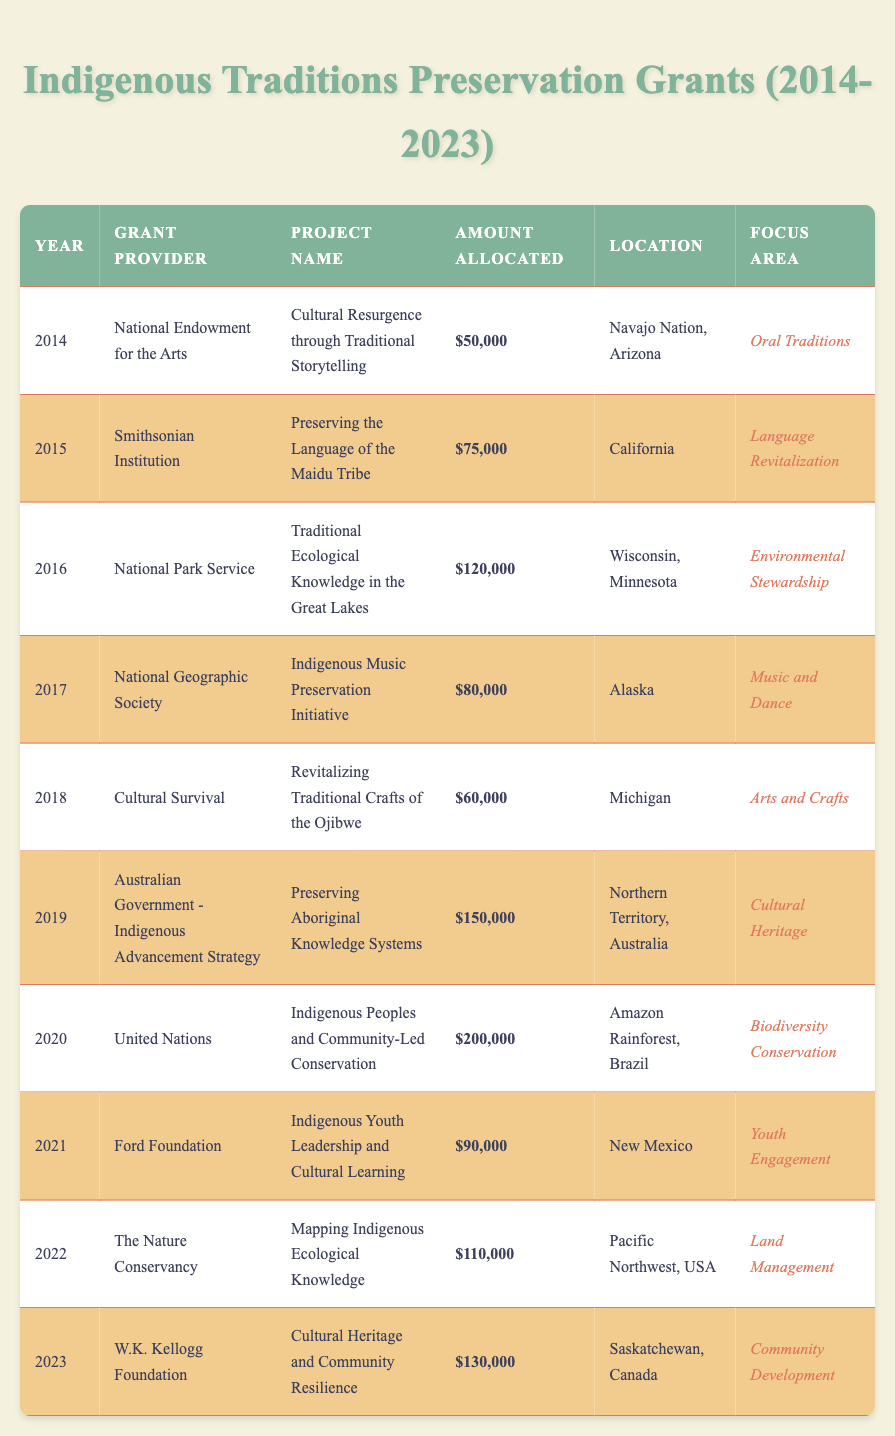What is the largest grant amount allocated in a single year? The table lists the amounts allocated each year, with the largest being $200,000 in 2020.
Answer: $200,000 Which project focused on language revitalization? The project "Preserving the Language of the Maidu Tribe" in 2015 targets language revitalization and is listed in the table.
Answer: Preserving the Language of the Maidu Tribe In which year was the "Cultural Resurgence through Traditional Storytelling" project funded? Referring to the year column, this project is from 2014, as evidenced by the specific entry in the table.
Answer: 2014 How many projects received funding for community development? Looking through the table, only one project from 2023 is focused on community development.
Answer: 1 What is the total amount allocated to all projects in the year 2019? For 2019, the only grant amount indicated is $150,000. Thus, the total for that year is $150,000.
Answer: $150,000 Which grant provider funded projects in both 2018 and 2019? The providers for these years are "Cultural Survival" for 2018 and "Australian Government - Indigenous Advancement Strategy" for 2019, indicating they are different; thus, no single provider funded both years.
Answer: No What is the average grant amount allocated per year over the ten years? The total amount allocated across all projects is $1,085,000 (sum over all amounts divided by 10 years gives $108,500). Thus, the average is calculated as $1,085,000 / 10 = $108,500.
Answer: $108,500 Which focus area has received the highest allocation over the decade? The "Biodiversity Conservation" focus area in 2020 received $200,000, the highest allocation, surpassing others.
Answer: Biodiversity Conservation How did the grant amount for 2021 compare to the amount for 2022? The amount for 2021 is $90,000 and for 2022 is $110,000. The amount for 2022 is greater by $20,000.
Answer: 20,000 List the two projects with a focus on arts and crafts. The table shows "Revitalizing Traditional Crafts of the Ojibwe" (2018) as the only project focusing on arts and crafts, meaning there is only one project listed.
Answer: 1 project 